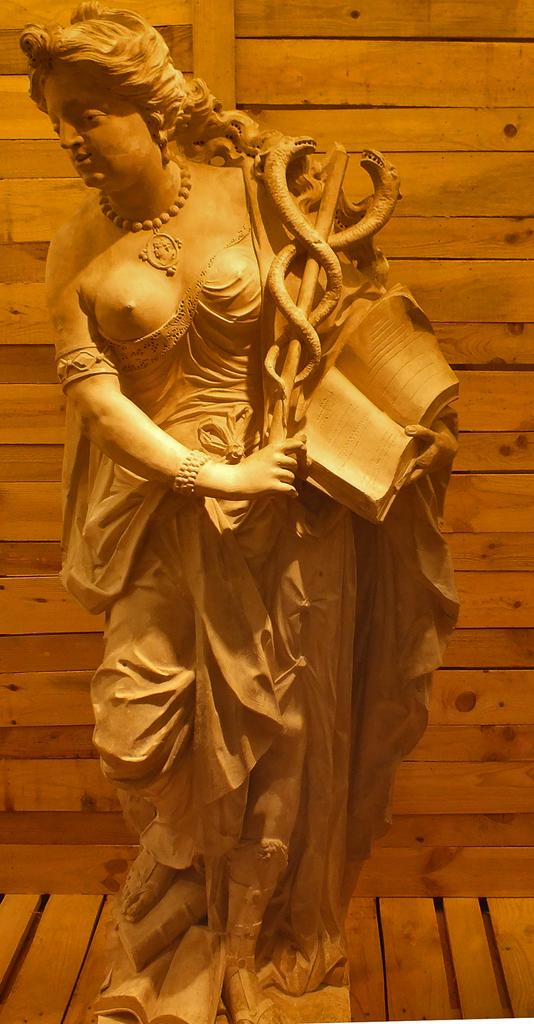What is the main subject of the wooden sculpture in the image? The main subject of the wooden sculpture in the image is a woman. What is the woman holding in the sculpture? The woman is holding a book in the sculpture. Are there any other objects held by the woman in the sculpture? Yes, there is another object held by the woman in the sculpture. What can be seen in the background of the image? There is a wooden wall in the background of the image. How many zebras are visible in the image? There are no zebras present in the image. What type of fruit is being held by the woman in the sculpture? The provided facts do not mention any fruit being held by the woman in the sculpture. 